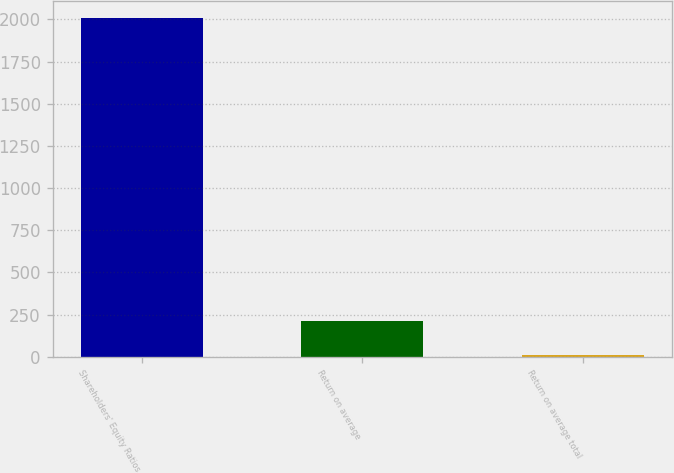Convert chart to OTSL. <chart><loc_0><loc_0><loc_500><loc_500><bar_chart><fcel>Shareholders' Equity Ratios<fcel>Return on average<fcel>Return on average total<nl><fcel>2007<fcel>210.24<fcel>10.6<nl></chart> 